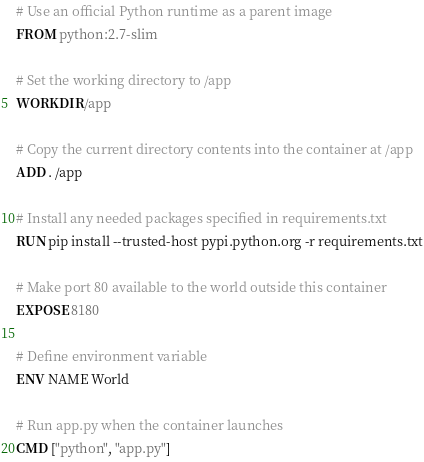<code> <loc_0><loc_0><loc_500><loc_500><_Dockerfile_># Use an official Python runtime as a parent image
FROM python:2.7-slim

# Set the working directory to /app
WORKDIR /app

# Copy the current directory contents into the container at /app
ADD . /app

# Install any needed packages specified in requirements.txt
RUN pip install --trusted-host pypi.python.org -r requirements.txt

# Make port 80 available to the world outside this container
EXPOSE 8180

# Define environment variable
ENV NAME World

# Run app.py when the container launches
CMD ["python", "app.py"]
</code> 